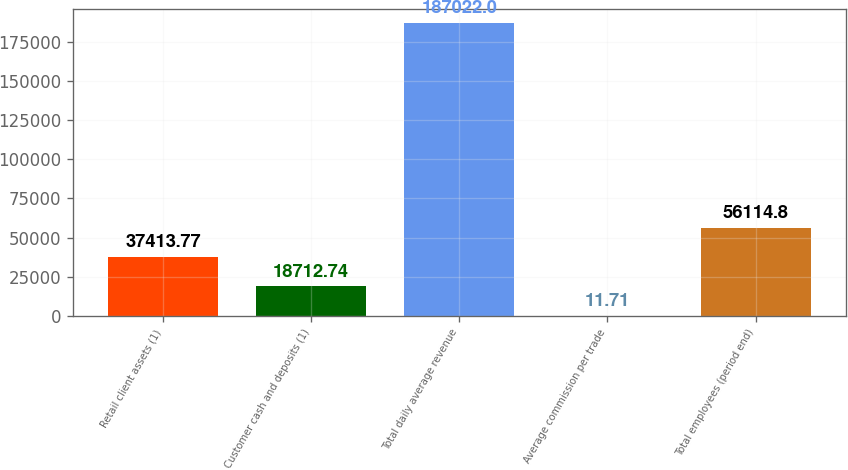Convert chart. <chart><loc_0><loc_0><loc_500><loc_500><bar_chart><fcel>Retail client assets (1)<fcel>Customer cash and deposits (1)<fcel>Total daily average revenue<fcel>Average commission per trade<fcel>Total employees (period end)<nl><fcel>37413.8<fcel>18712.7<fcel>187022<fcel>11.71<fcel>56114.8<nl></chart> 